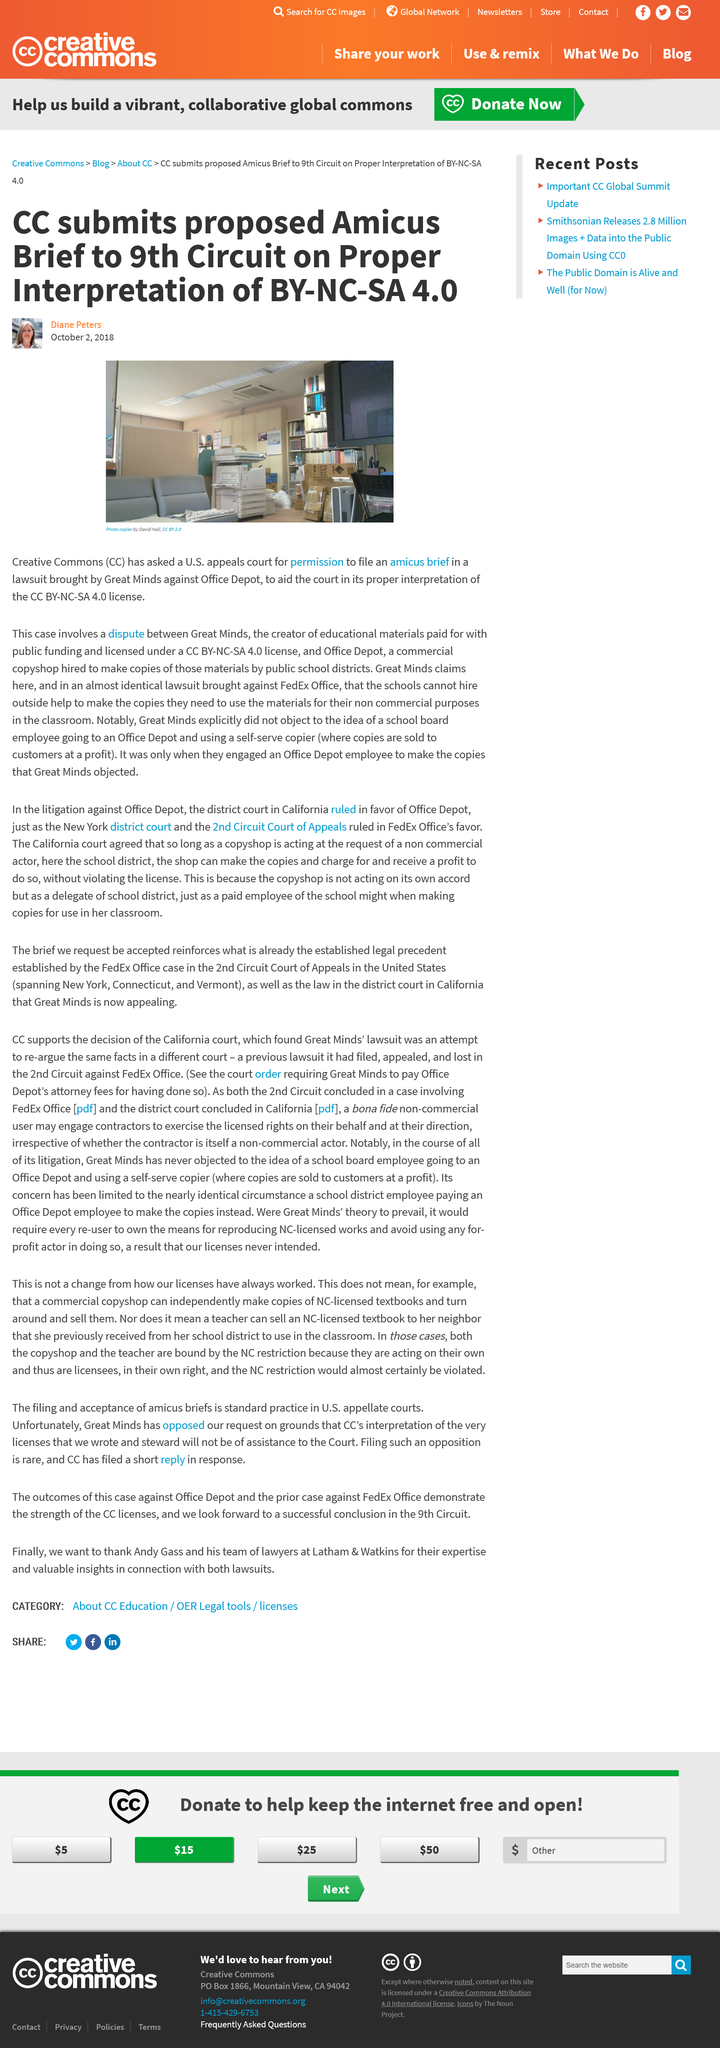Mention a couple of crucial points in this snapshot. The dispute involves Great minds and Office Depot. The CC has requested the U.S. appeals court's permission to file an amicus brief. An amicus brief was requested in the case involving Great Minds and Office Depot. 